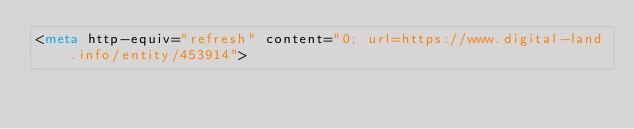Convert code to text. <code><loc_0><loc_0><loc_500><loc_500><_HTML_><meta http-equiv="refresh" content="0; url=https://www.digital-land.info/entity/453914"></code> 